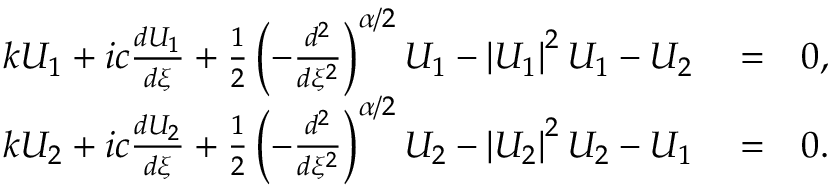Convert formula to latex. <formula><loc_0><loc_0><loc_500><loc_500>\begin{array} { r l r } { k U _ { 1 } + i c \frac { d U _ { 1 } } { d \xi } + \frac { 1 } { 2 } \left ( - \frac { d ^ { 2 } } { d \xi ^ { 2 } } \right ) ^ { \alpha / 2 } U _ { 1 } - \left | U _ { 1 } \right | ^ { 2 } U _ { 1 } - U _ { 2 } } & = } & { 0 , } \\ { k U _ { 2 } + i c \frac { d U _ { 2 } } { d \xi } + \frac { 1 } { 2 } \left ( - \frac { d ^ { 2 } } { d \xi ^ { 2 } } \right ) ^ { \alpha / 2 } U _ { 2 } - \left | U _ { 2 } \right | ^ { 2 } U _ { 2 } - U _ { 1 } } & = } & { 0 . } \end{array}</formula> 